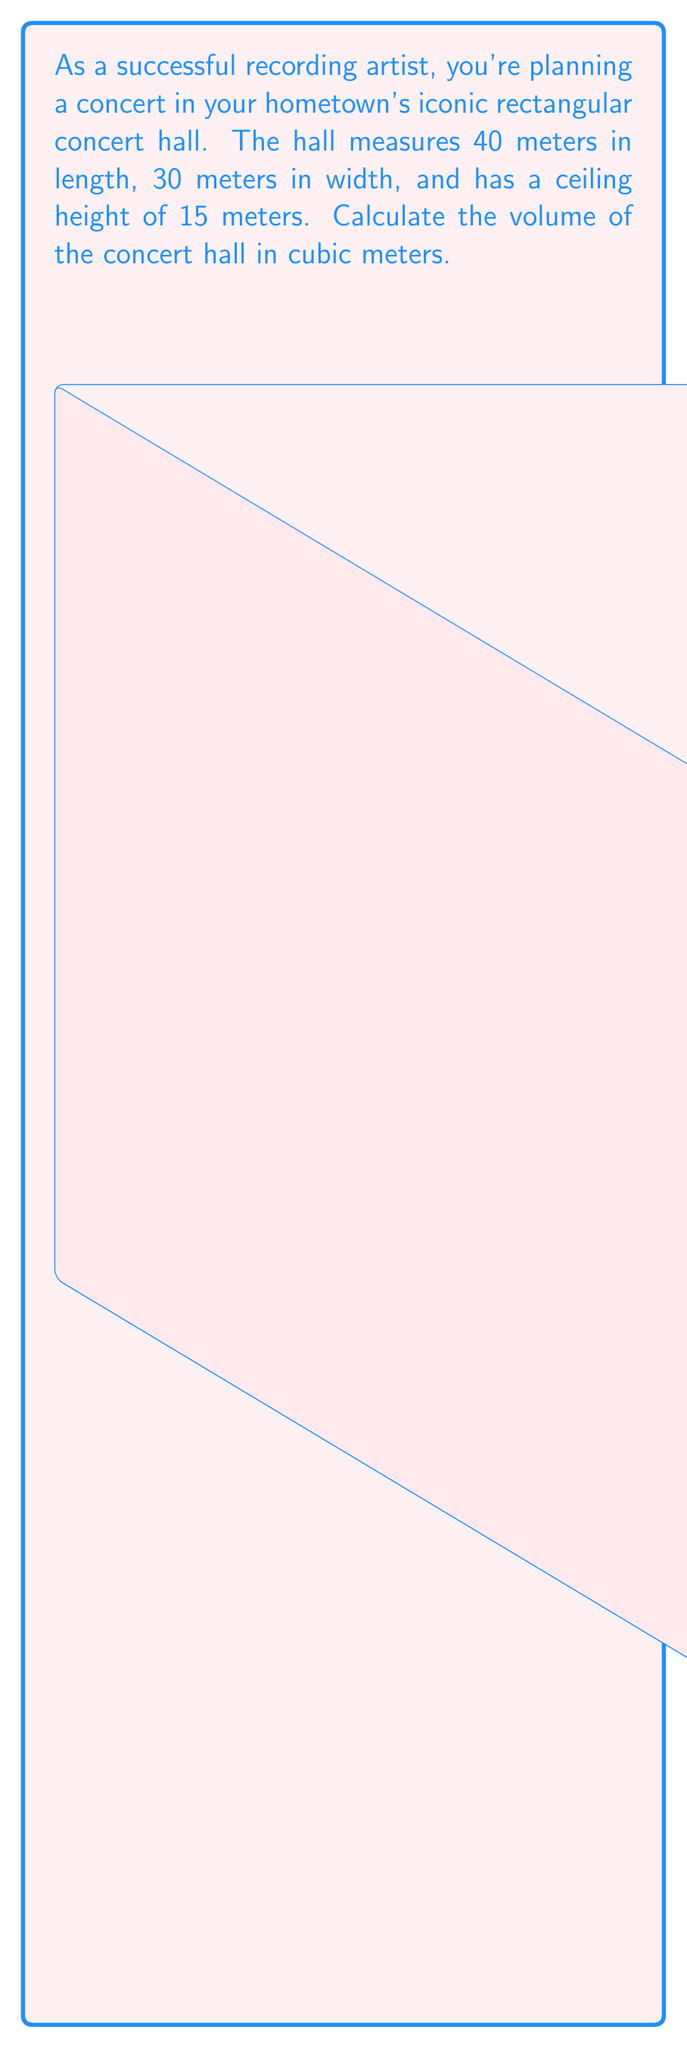Help me with this question. To calculate the volume of a rectangular concert hall, we need to multiply its length, width, and height. 

Given:
- Length (l) = 40 meters
- Width (w) = 30 meters
- Height (h) = 15 meters

The formula for the volume of a rectangular prism is:

$$ V = l \times w \times h $$

Substituting the values:

$$ V = 40 \text{ m} \times 30 \text{ m} \times 15 \text{ m} $$

Calculating:

$$ V = 18,000 \text{ m}^3 $$

Therefore, the volume of the concert hall is 18,000 cubic meters.
Answer: 18,000 m³ 